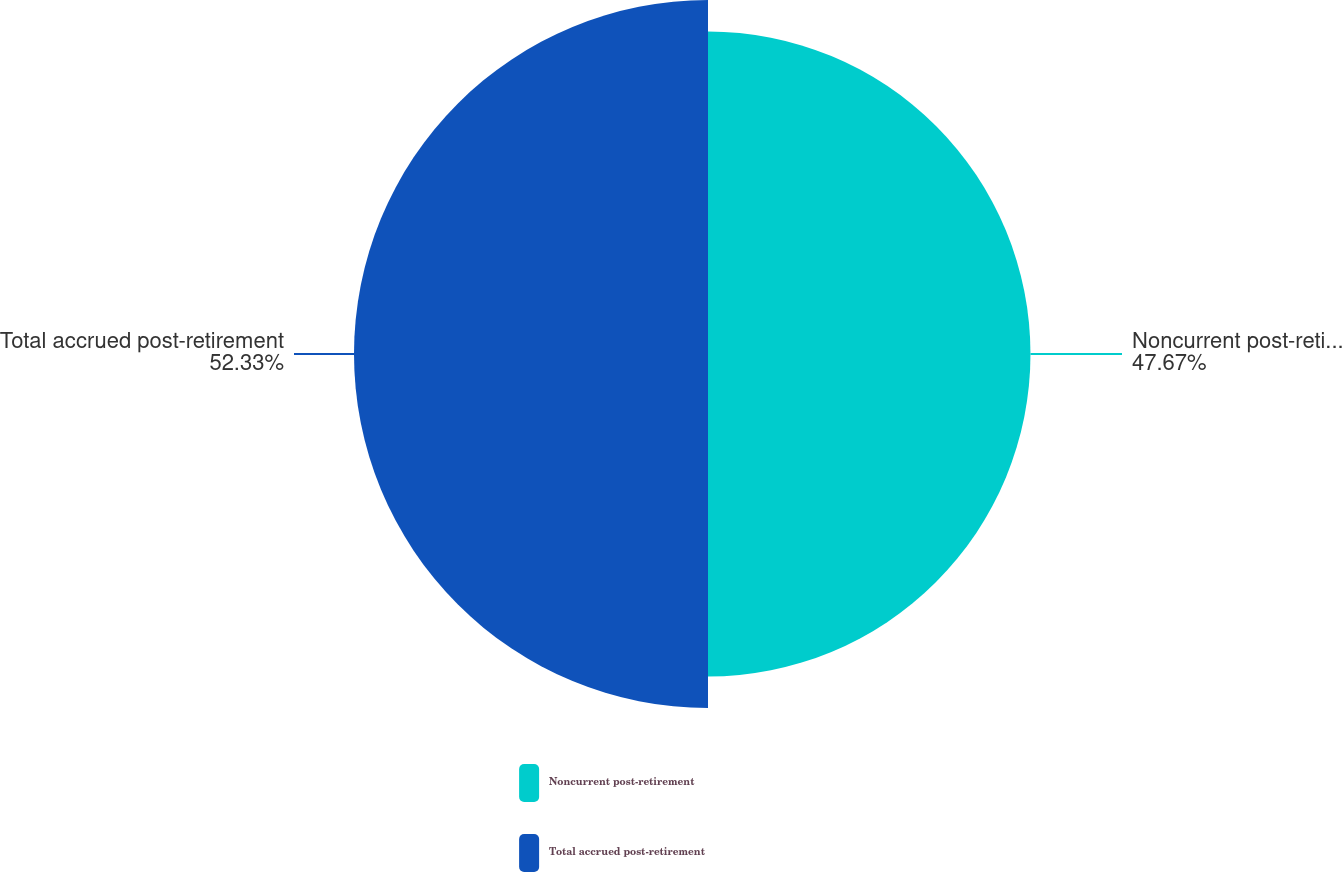<chart> <loc_0><loc_0><loc_500><loc_500><pie_chart><fcel>Noncurrent post-retirement<fcel>Total accrued post-retirement<nl><fcel>47.67%<fcel>52.33%<nl></chart> 